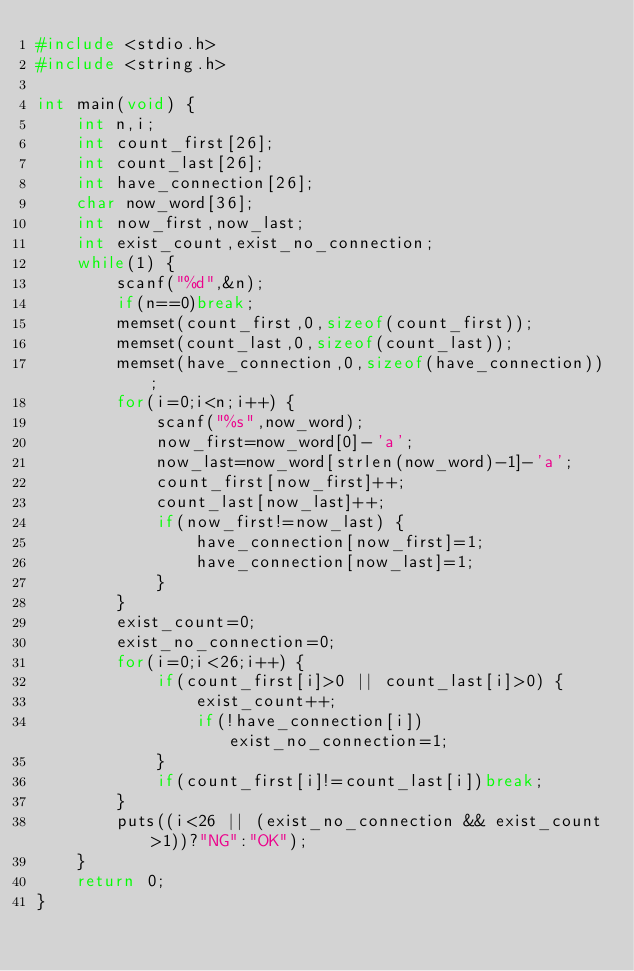Convert code to text. <code><loc_0><loc_0><loc_500><loc_500><_C_>#include <stdio.h>
#include <string.h>

int main(void) {
	int n,i;
	int count_first[26];
	int count_last[26];
	int have_connection[26];
	char now_word[36];
	int now_first,now_last;
	int exist_count,exist_no_connection;
	while(1) {
		scanf("%d",&n);
		if(n==0)break;
		memset(count_first,0,sizeof(count_first));
		memset(count_last,0,sizeof(count_last));
		memset(have_connection,0,sizeof(have_connection));
		for(i=0;i<n;i++) {
			scanf("%s",now_word);
			now_first=now_word[0]-'a';
			now_last=now_word[strlen(now_word)-1]-'a';
			count_first[now_first]++;
			count_last[now_last]++;
			if(now_first!=now_last) {
				have_connection[now_first]=1;
				have_connection[now_last]=1;
			}
		}
		exist_count=0;
		exist_no_connection=0;
		for(i=0;i<26;i++) {
			if(count_first[i]>0 || count_last[i]>0) {
				exist_count++;
				if(!have_connection[i])exist_no_connection=1;
			}
			if(count_first[i]!=count_last[i])break;
		}
		puts((i<26 || (exist_no_connection && exist_count>1))?"NG":"OK");
	}
	return 0;
}</code> 